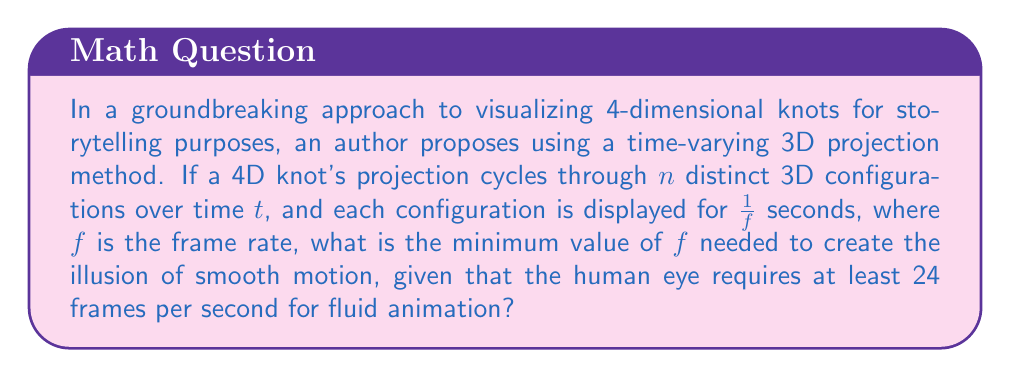Give your solution to this math problem. To solve this problem, we need to follow these steps:

1) First, we need to understand that the total cycle time for the 4D knot visualization is:

   $$T = \frac{n}{f}$$

   Where $T$ is the total cycle time in seconds, $n$ is the number of distinct 3D configurations, and $f$ is the frame rate.

2) For smooth motion, we need at least 24 frames per second. This means that the total cycle time should not exceed $\frac{1}{24}$ seconds:

   $$\frac{n}{f} \leq \frac{1}{24}$$

3) Solving for $f$:

   $$f \geq 24n$$

4) Therefore, the minimum frame rate needed is $24n$ frames per second.

5) However, the question asks for the minimum value of $f$. Since $f$ must be an integer (we can't have fractional frames), we need to round up to the nearest whole number:

   $$f_{min} = \lceil 24n \rceil$$

   Where $\lceil \rceil$ denotes the ceiling function.

This approach ensures that the visualization will appear smooth while efficiently representing the complex 4D structure in a way that can be integrated into a narrative.
Answer: $\lceil 24n \rceil$ fps 